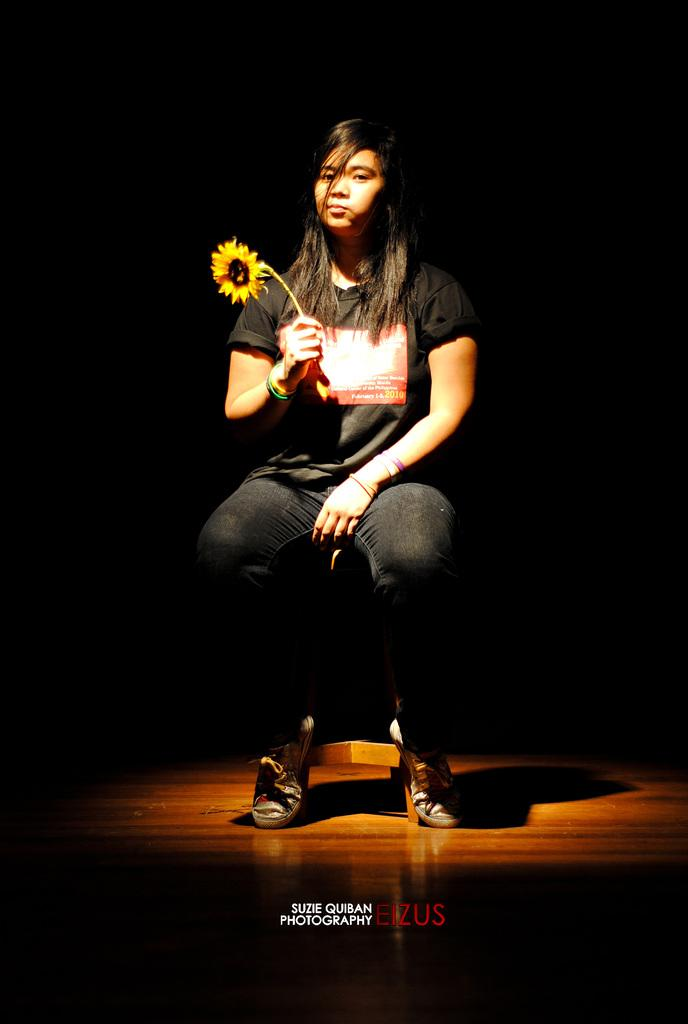Who is present in the image? There is a woman in the image. What is the woman doing in the image? The woman is sitting on a chair. What object is the woman holding in the image? The woman is holding a flower. What type of pancake is the woman eating in the image? There is no pancake present in the image; the woman is holding a flower. 